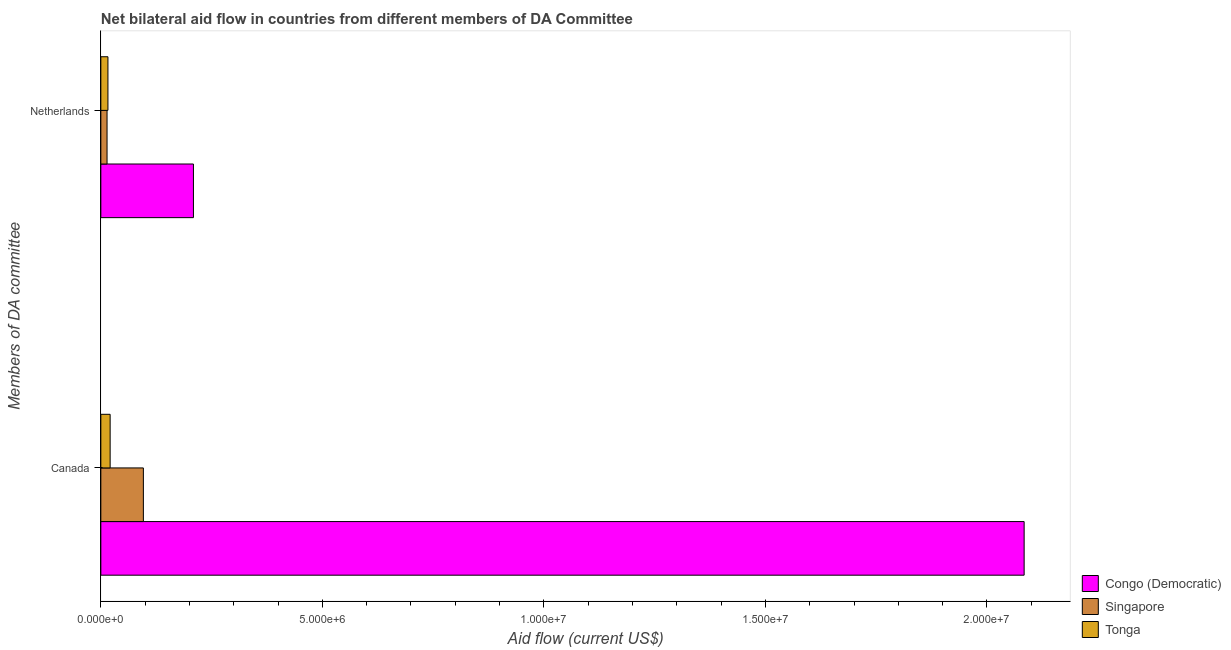How many different coloured bars are there?
Provide a short and direct response. 3. How many groups of bars are there?
Ensure brevity in your answer.  2. How many bars are there on the 2nd tick from the top?
Your answer should be compact. 3. How many bars are there on the 1st tick from the bottom?
Offer a very short reply. 3. What is the label of the 1st group of bars from the top?
Keep it short and to the point. Netherlands. What is the amount of aid given by netherlands in Singapore?
Give a very brief answer. 1.40e+05. Across all countries, what is the maximum amount of aid given by canada?
Your response must be concise. 2.08e+07. Across all countries, what is the minimum amount of aid given by canada?
Keep it short and to the point. 2.10e+05. In which country was the amount of aid given by canada maximum?
Provide a short and direct response. Congo (Democratic). In which country was the amount of aid given by netherlands minimum?
Offer a very short reply. Singapore. What is the total amount of aid given by netherlands in the graph?
Make the answer very short. 2.39e+06. What is the difference between the amount of aid given by netherlands in Tonga and that in Singapore?
Keep it short and to the point. 2.00e+04. What is the difference between the amount of aid given by canada in Tonga and the amount of aid given by netherlands in Congo (Democratic)?
Provide a succinct answer. -1.88e+06. What is the average amount of aid given by canada per country?
Ensure brevity in your answer.  7.34e+06. What is the difference between the amount of aid given by netherlands and amount of aid given by canada in Congo (Democratic)?
Offer a very short reply. -1.88e+07. In how many countries, is the amount of aid given by canada greater than 7000000 US$?
Make the answer very short. 1. What is the ratio of the amount of aid given by canada in Congo (Democratic) to that in Tonga?
Make the answer very short. 99.24. What does the 3rd bar from the top in Canada represents?
Offer a terse response. Congo (Democratic). What does the 3rd bar from the bottom in Netherlands represents?
Keep it short and to the point. Tonga. How many bars are there?
Your answer should be compact. 6. How many countries are there in the graph?
Make the answer very short. 3. What is the difference between two consecutive major ticks on the X-axis?
Make the answer very short. 5.00e+06. Are the values on the major ticks of X-axis written in scientific E-notation?
Keep it short and to the point. Yes. Where does the legend appear in the graph?
Provide a short and direct response. Bottom right. How many legend labels are there?
Keep it short and to the point. 3. What is the title of the graph?
Provide a succinct answer. Net bilateral aid flow in countries from different members of DA Committee. What is the label or title of the X-axis?
Your answer should be compact. Aid flow (current US$). What is the label or title of the Y-axis?
Make the answer very short. Members of DA committee. What is the Aid flow (current US$) of Congo (Democratic) in Canada?
Make the answer very short. 2.08e+07. What is the Aid flow (current US$) of Singapore in Canada?
Provide a succinct answer. 9.60e+05. What is the Aid flow (current US$) of Congo (Democratic) in Netherlands?
Offer a very short reply. 2.09e+06. Across all Members of DA committee, what is the maximum Aid flow (current US$) in Congo (Democratic)?
Your answer should be compact. 2.08e+07. Across all Members of DA committee, what is the maximum Aid flow (current US$) of Singapore?
Offer a very short reply. 9.60e+05. Across all Members of DA committee, what is the maximum Aid flow (current US$) of Tonga?
Offer a very short reply. 2.10e+05. Across all Members of DA committee, what is the minimum Aid flow (current US$) in Congo (Democratic)?
Give a very brief answer. 2.09e+06. Across all Members of DA committee, what is the minimum Aid flow (current US$) in Singapore?
Provide a short and direct response. 1.40e+05. What is the total Aid flow (current US$) of Congo (Democratic) in the graph?
Your response must be concise. 2.29e+07. What is the total Aid flow (current US$) of Singapore in the graph?
Make the answer very short. 1.10e+06. What is the difference between the Aid flow (current US$) of Congo (Democratic) in Canada and that in Netherlands?
Your response must be concise. 1.88e+07. What is the difference between the Aid flow (current US$) of Singapore in Canada and that in Netherlands?
Offer a very short reply. 8.20e+05. What is the difference between the Aid flow (current US$) in Tonga in Canada and that in Netherlands?
Provide a short and direct response. 5.00e+04. What is the difference between the Aid flow (current US$) of Congo (Democratic) in Canada and the Aid flow (current US$) of Singapore in Netherlands?
Your response must be concise. 2.07e+07. What is the difference between the Aid flow (current US$) in Congo (Democratic) in Canada and the Aid flow (current US$) in Tonga in Netherlands?
Provide a short and direct response. 2.07e+07. What is the difference between the Aid flow (current US$) of Singapore in Canada and the Aid flow (current US$) of Tonga in Netherlands?
Offer a very short reply. 8.00e+05. What is the average Aid flow (current US$) of Congo (Democratic) per Members of DA committee?
Your answer should be very brief. 1.15e+07. What is the average Aid flow (current US$) in Singapore per Members of DA committee?
Provide a short and direct response. 5.50e+05. What is the average Aid flow (current US$) in Tonga per Members of DA committee?
Provide a succinct answer. 1.85e+05. What is the difference between the Aid flow (current US$) of Congo (Democratic) and Aid flow (current US$) of Singapore in Canada?
Your answer should be very brief. 1.99e+07. What is the difference between the Aid flow (current US$) of Congo (Democratic) and Aid flow (current US$) of Tonga in Canada?
Ensure brevity in your answer.  2.06e+07. What is the difference between the Aid flow (current US$) in Singapore and Aid flow (current US$) in Tonga in Canada?
Your answer should be very brief. 7.50e+05. What is the difference between the Aid flow (current US$) of Congo (Democratic) and Aid flow (current US$) of Singapore in Netherlands?
Give a very brief answer. 1.95e+06. What is the difference between the Aid flow (current US$) in Congo (Democratic) and Aid flow (current US$) in Tonga in Netherlands?
Make the answer very short. 1.93e+06. What is the difference between the Aid flow (current US$) in Singapore and Aid flow (current US$) in Tonga in Netherlands?
Your response must be concise. -2.00e+04. What is the ratio of the Aid flow (current US$) in Congo (Democratic) in Canada to that in Netherlands?
Ensure brevity in your answer.  9.97. What is the ratio of the Aid flow (current US$) of Singapore in Canada to that in Netherlands?
Provide a short and direct response. 6.86. What is the ratio of the Aid flow (current US$) of Tonga in Canada to that in Netherlands?
Offer a very short reply. 1.31. What is the difference between the highest and the second highest Aid flow (current US$) in Congo (Democratic)?
Offer a very short reply. 1.88e+07. What is the difference between the highest and the second highest Aid flow (current US$) of Singapore?
Offer a very short reply. 8.20e+05. What is the difference between the highest and the second highest Aid flow (current US$) in Tonga?
Your answer should be very brief. 5.00e+04. What is the difference between the highest and the lowest Aid flow (current US$) in Congo (Democratic)?
Your response must be concise. 1.88e+07. What is the difference between the highest and the lowest Aid flow (current US$) of Singapore?
Make the answer very short. 8.20e+05. 